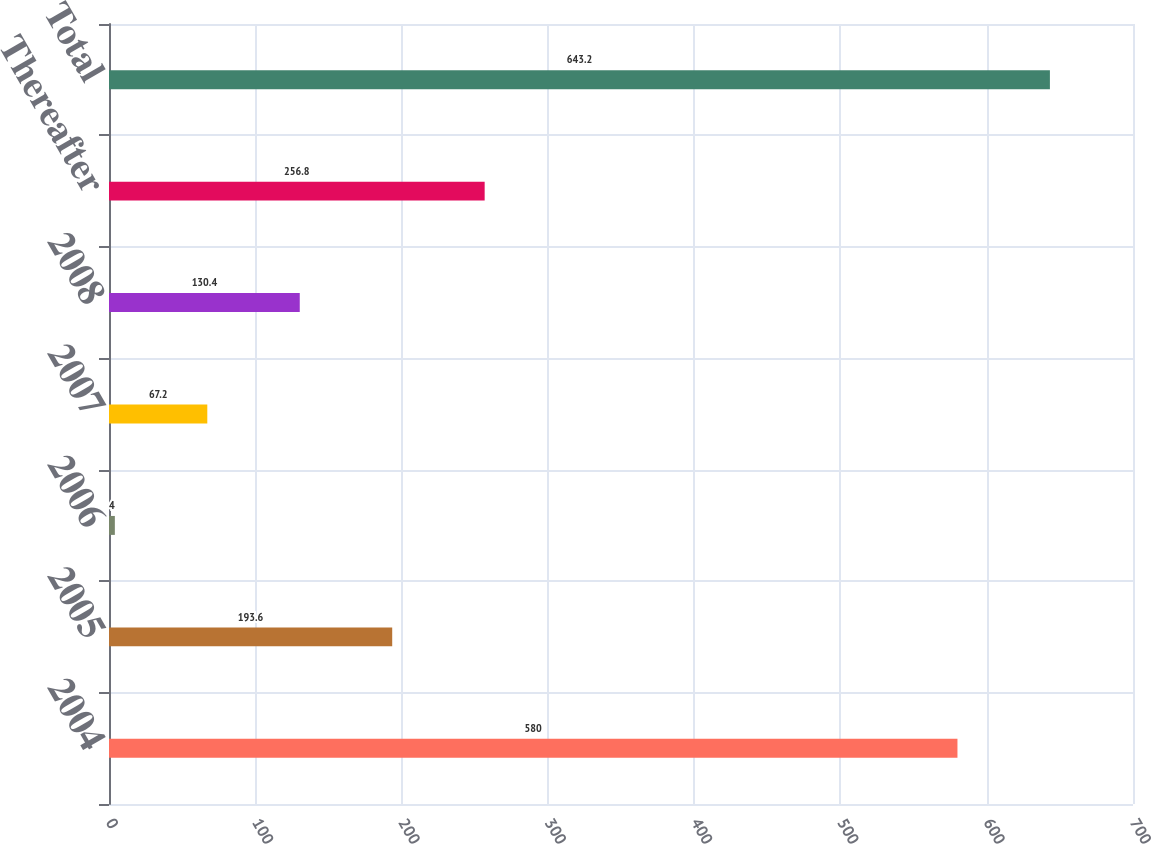<chart> <loc_0><loc_0><loc_500><loc_500><bar_chart><fcel>2004<fcel>2005<fcel>2006<fcel>2007<fcel>2008<fcel>Thereafter<fcel>Total<nl><fcel>580<fcel>193.6<fcel>4<fcel>67.2<fcel>130.4<fcel>256.8<fcel>643.2<nl></chart> 